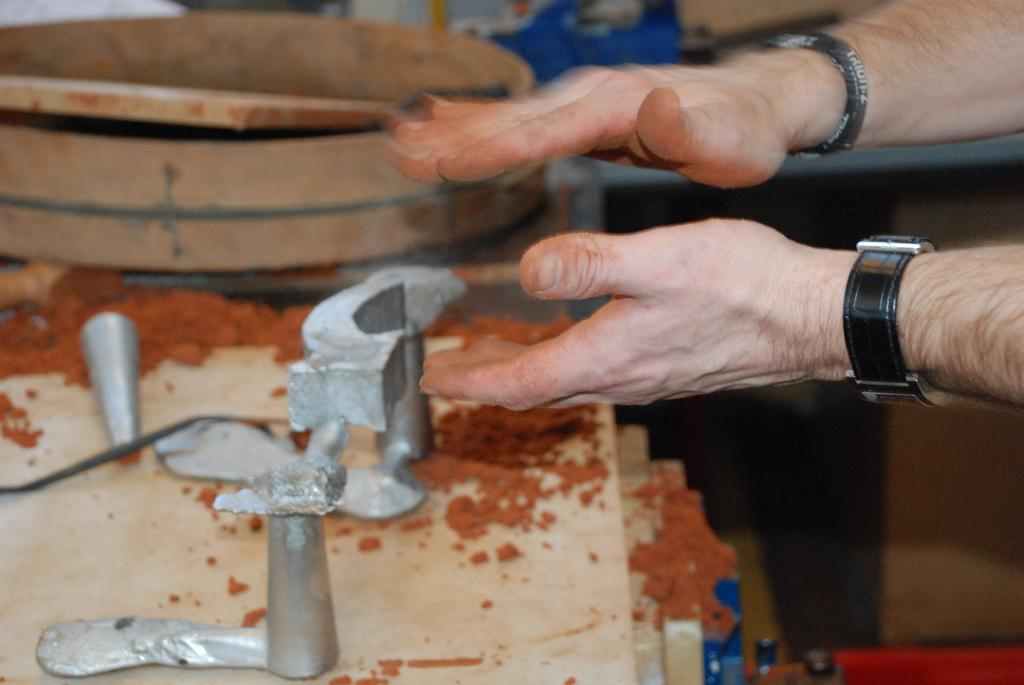What body parts are visible in the image? There are persons' hands in the image. What type of object can be seen on the left side of the image? There is a wooden object on the left side of the image. What is the location of the objects in the image? The objects are on a table in the image. What type of harmony is being played on the wooden object in the image? There is no indication of any music or harmony being played in the image; it only shows hands and a wooden object on a table. 